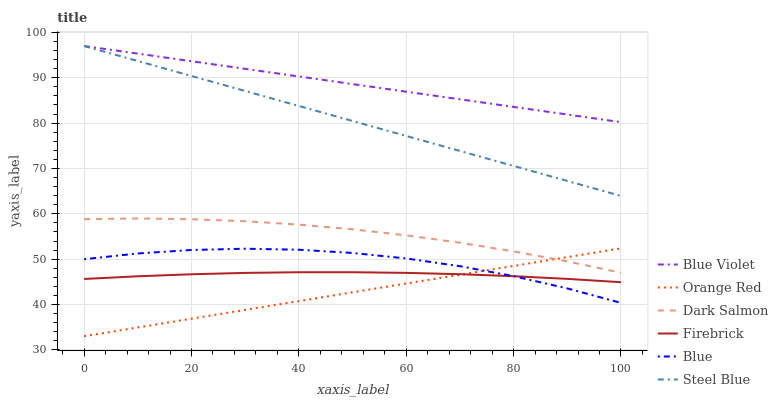Does Orange Red have the minimum area under the curve?
Answer yes or no. Yes. Does Blue Violet have the maximum area under the curve?
Answer yes or no. Yes. Does Firebrick have the minimum area under the curve?
Answer yes or no. No. Does Firebrick have the maximum area under the curve?
Answer yes or no. No. Is Blue Violet the smoothest?
Answer yes or no. Yes. Is Blue the roughest?
Answer yes or no. Yes. Is Firebrick the smoothest?
Answer yes or no. No. Is Firebrick the roughest?
Answer yes or no. No. Does Orange Red have the lowest value?
Answer yes or no. Yes. Does Firebrick have the lowest value?
Answer yes or no. No. Does Blue Violet have the highest value?
Answer yes or no. Yes. Does Firebrick have the highest value?
Answer yes or no. No. Is Blue less than Dark Salmon?
Answer yes or no. Yes. Is Dark Salmon greater than Blue?
Answer yes or no. Yes. Does Orange Red intersect Blue?
Answer yes or no. Yes. Is Orange Red less than Blue?
Answer yes or no. No. Is Orange Red greater than Blue?
Answer yes or no. No. Does Blue intersect Dark Salmon?
Answer yes or no. No. 